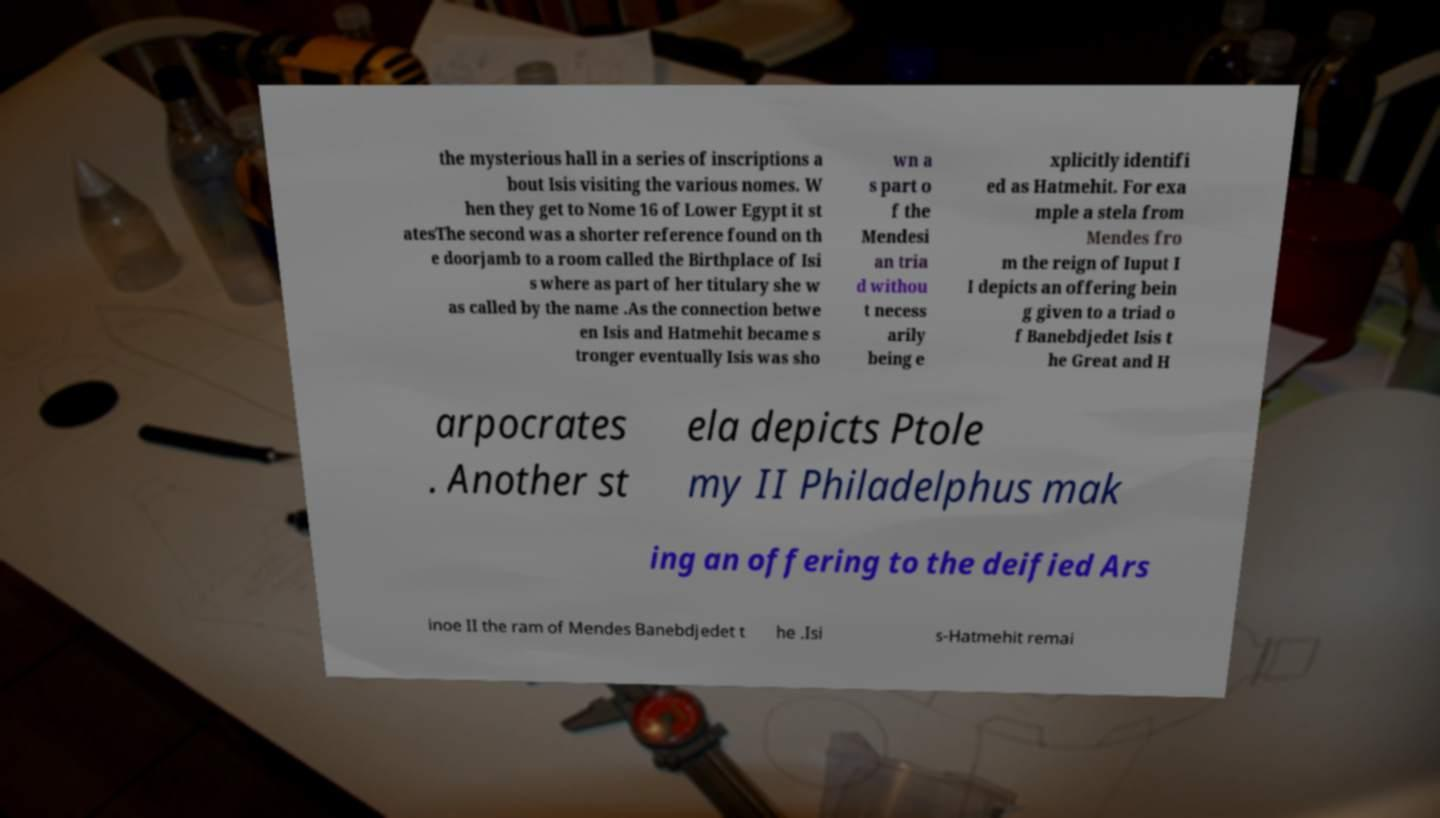Can you read and provide the text displayed in the image?This photo seems to have some interesting text. Can you extract and type it out for me? the mysterious hall in a series of inscriptions a bout Isis visiting the various nomes. W hen they get to Nome 16 of Lower Egypt it st atesThe second was a shorter reference found on th e doorjamb to a room called the Birthplace of Isi s where as part of her titulary she w as called by the name .As the connection betwe en Isis and Hatmehit became s tronger eventually Isis was sho wn a s part o f the Mendesi an tria d withou t necess arily being e xplicitly identifi ed as Hatmehit. For exa mple a stela from Mendes fro m the reign of Iuput I I depicts an offering bein g given to a triad o f Banebdjedet Isis t he Great and H arpocrates . Another st ela depicts Ptole my II Philadelphus mak ing an offering to the deified Ars inoe II the ram of Mendes Banebdjedet t he .Isi s-Hatmehit remai 